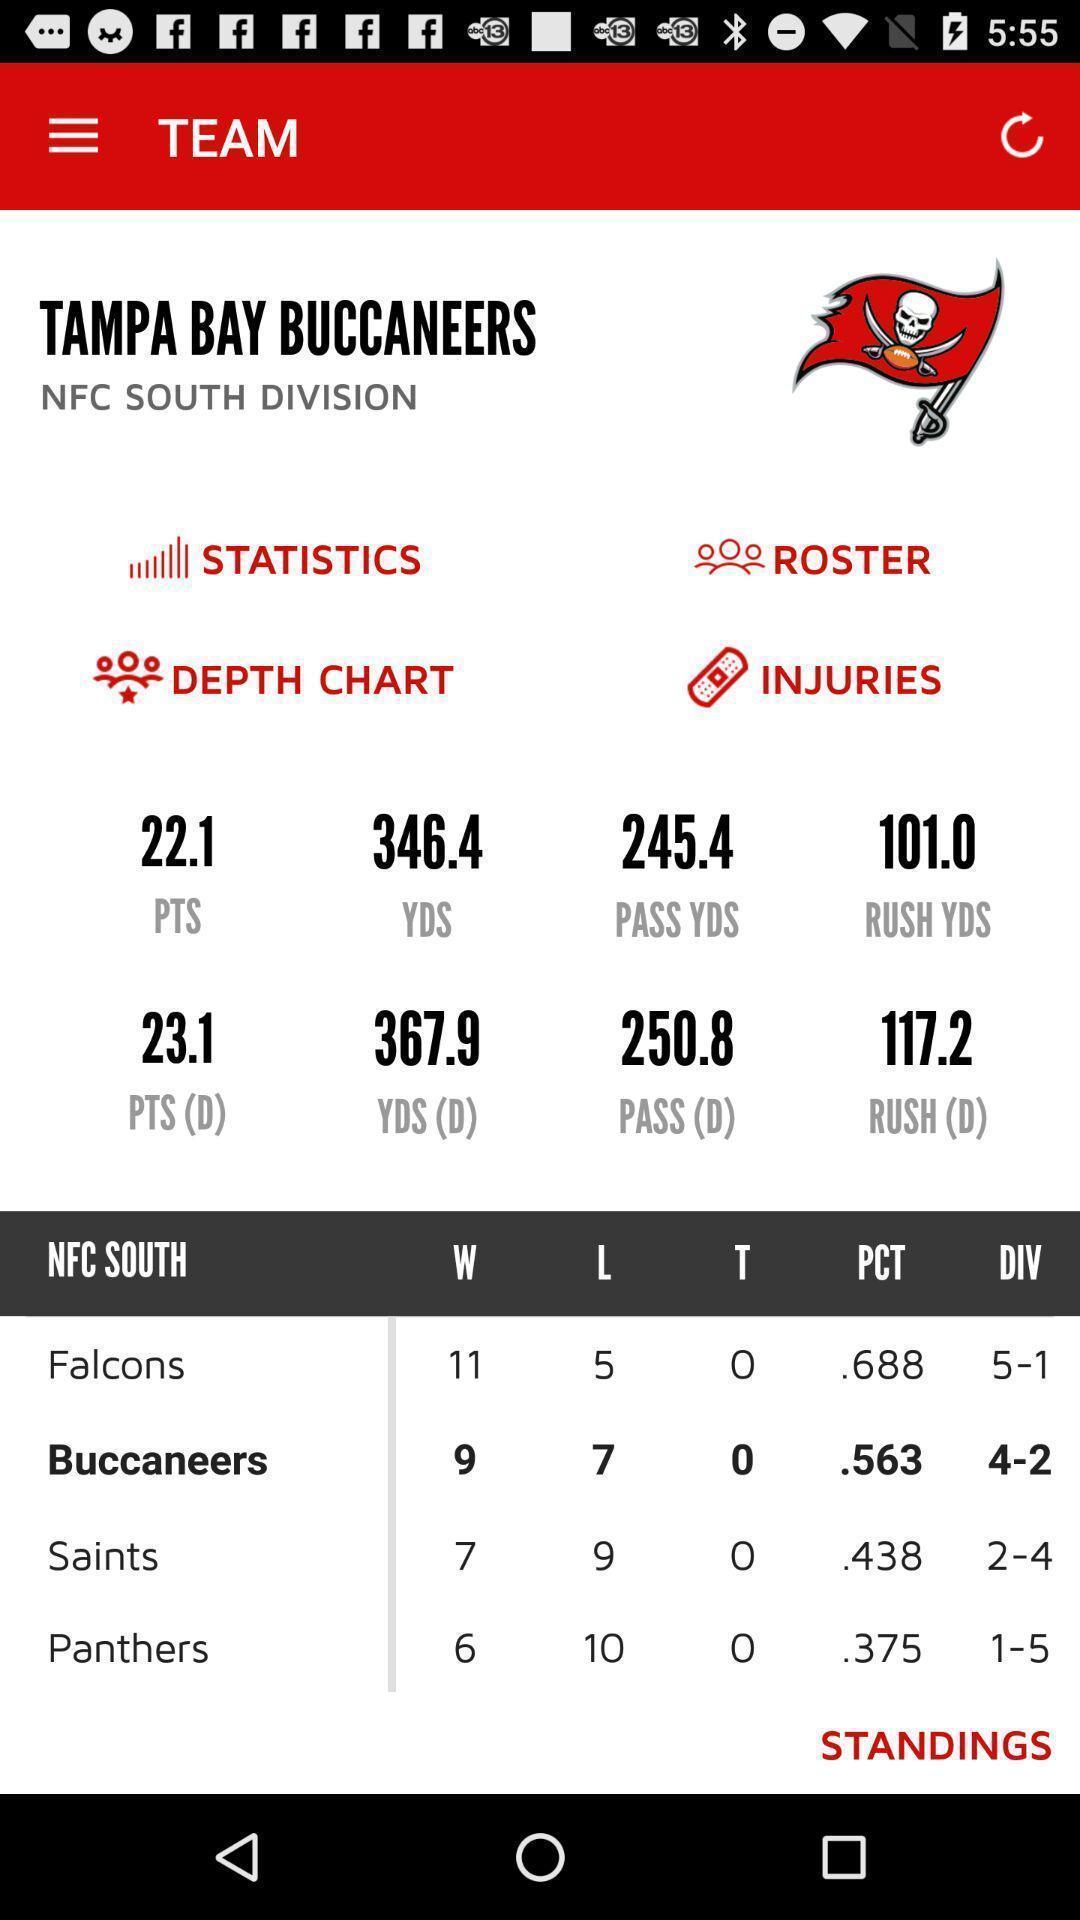Tell me what you see in this picture. Page showing team details in a sports app. 